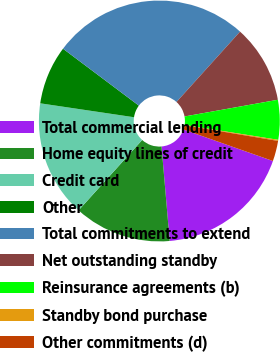Convert chart. <chart><loc_0><loc_0><loc_500><loc_500><pie_chart><fcel>Total commercial lending<fcel>Home equity lines of credit<fcel>Credit card<fcel>Other<fcel>Total commitments to extend<fcel>Net outstanding standby<fcel>Reinsurance agreements (b)<fcel>Standby bond purchase<fcel>Other commitments (d)<nl><fcel>18.24%<fcel>13.07%<fcel>15.65%<fcel>7.9%<fcel>26.45%<fcel>10.49%<fcel>5.32%<fcel>0.15%<fcel>2.74%<nl></chart> 